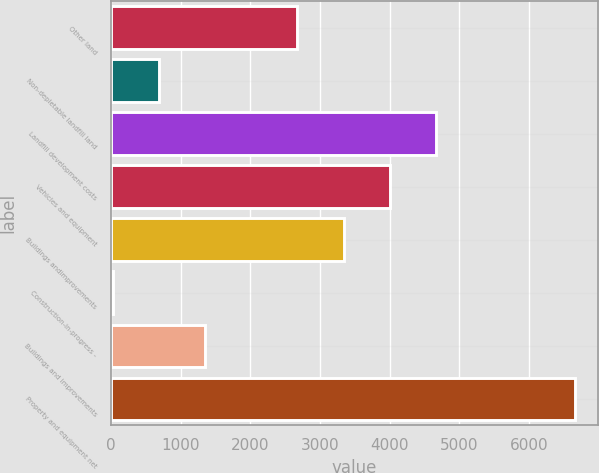Convert chart. <chart><loc_0><loc_0><loc_500><loc_500><bar_chart><fcel>Other land<fcel>Non-depletable landfill land<fcel>Landfill development costs<fcel>Vehicles and equipment<fcel>Buildings andimprovements<fcel>Construction-in-progress -<fcel>Buildings and improvements<fcel>Property and equipment net<nl><fcel>2676.88<fcel>686.47<fcel>4667.29<fcel>4003.82<fcel>3340.35<fcel>23<fcel>1349.94<fcel>6657.7<nl></chart> 